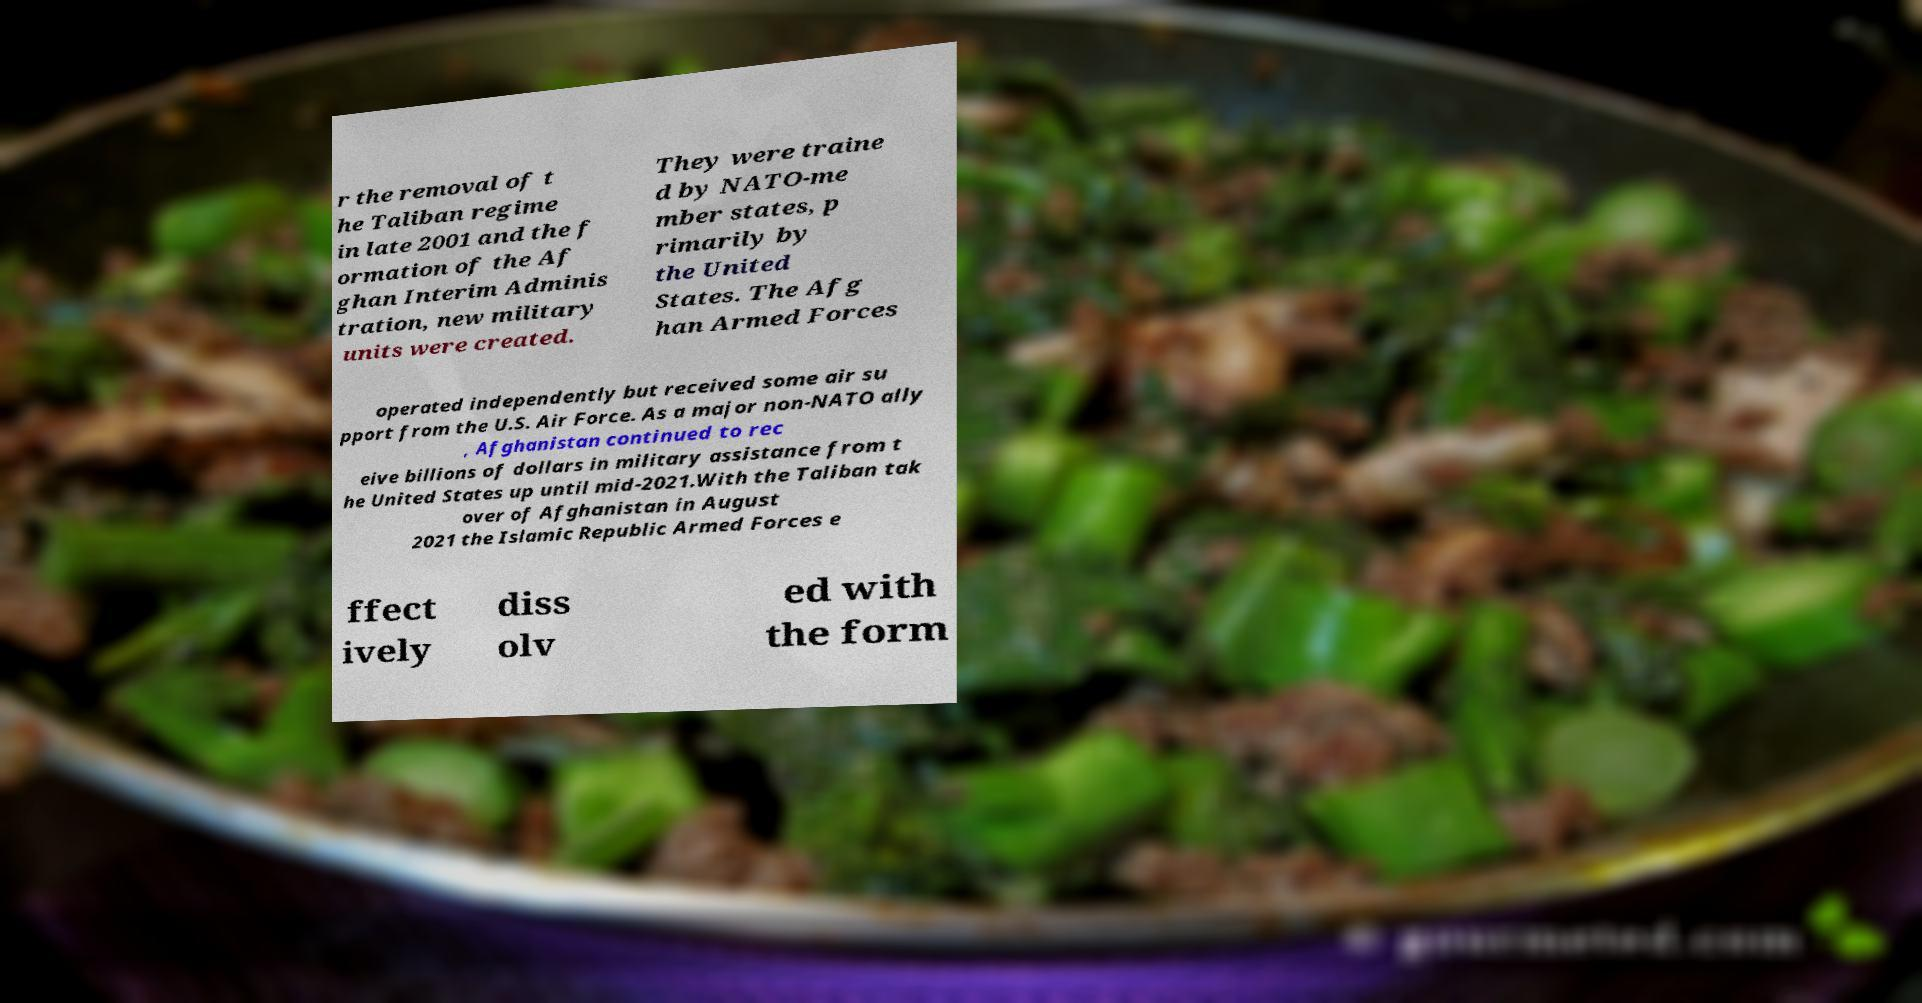There's text embedded in this image that I need extracted. Can you transcribe it verbatim? r the removal of t he Taliban regime in late 2001 and the f ormation of the Af ghan Interim Adminis tration, new military units were created. They were traine d by NATO-me mber states, p rimarily by the United States. The Afg han Armed Forces operated independently but received some air su pport from the U.S. Air Force. As a major non-NATO ally , Afghanistan continued to rec eive billions of dollars in military assistance from t he United States up until mid-2021.With the Taliban tak over of Afghanistan in August 2021 the Islamic Republic Armed Forces e ffect ively diss olv ed with the form 